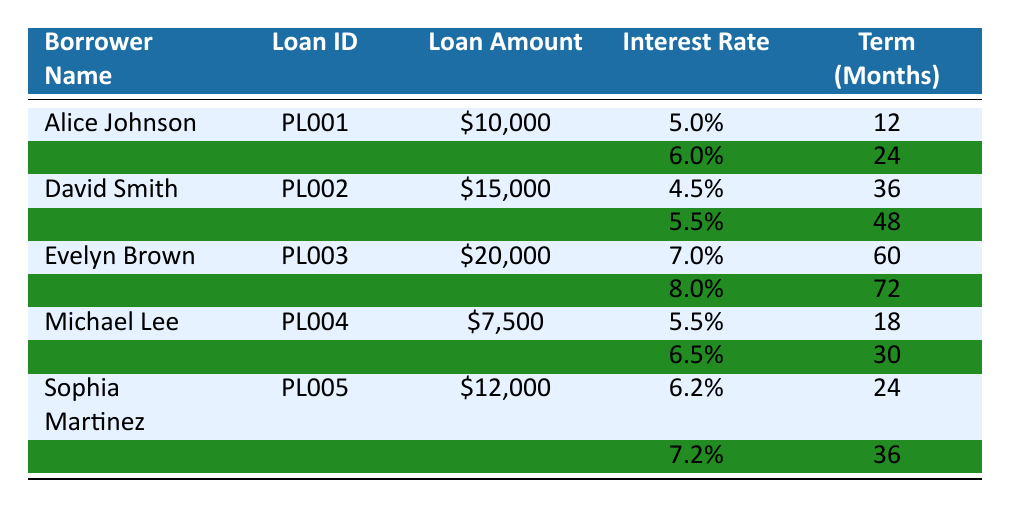What is the loan amount for Alice Johnson? The table shows that Alice Johnson's loan amount is listed in the row corresponding to her name. It clearly states that her loan amount is $10,000.
Answer: $10,000 What is the interest rate for David Smith's second loan? To find David Smith's second loan interest rate, we look at the second entry in his row, which indicates a rate of 5.5%.
Answer: 5.5% Which borrower has the largest loan amount? By comparing the loan amounts listed for each borrower, we find that Evelyn Brown has the largest loan amount, which is $20,000.
Answer: Evelyn Brown What is the total loan amount for all the borrowers combined? The total loan amount is calculated by summing the individual loan amounts: $10,000 + $15,000 + $20,000 + $7,500 + $12,000 = $64,500.
Answer: $64,500 Does Michael Lee have a loan term that is longer than 30 months? By examining Michael Lee's loans, the first loan has a term of 18 months and the second has a term of 30 months. Neither is longer than 30 months, so the answer is no.
Answer: No What is the difference in interest rates between Sophia Martinez's two loans? We look at Sophia's two interest rates: 6.2% for the first loan and 7.2% for the second loan. The difference is calculated as 7.2% - 6.2% = 1.0%.
Answer: 1.0% Which borrower has a loan term of 60 months or longer? We scan the table for loan terms of 60 months or longer. The only borrower fitting this criterion is Evelyn Brown, whose first loan has a 60-month term.
Answer: Evelyn Brown What is the average interest rate for all loans listed? The average interest rate is calculated by adding all interest rates (5.0% + 6.0% + 4.5% + 5.5% + 7.0% + 8.0% + 5.5% + 6.5% + 6.2% + 7.2%) which totals 56.0%. Dividing by the number of interest rates (10) gives an average of 5.6%.
Answer: 5.6% Is the loan term for Alice Johnson's first loan shorter than that of Michael Lee's first loan? Alice Johnson's first loan term is 12 months, and Michael Lee's first loan has a term of 18 months. Since 12 is less than 18, the answer is yes.
Answer: Yes 